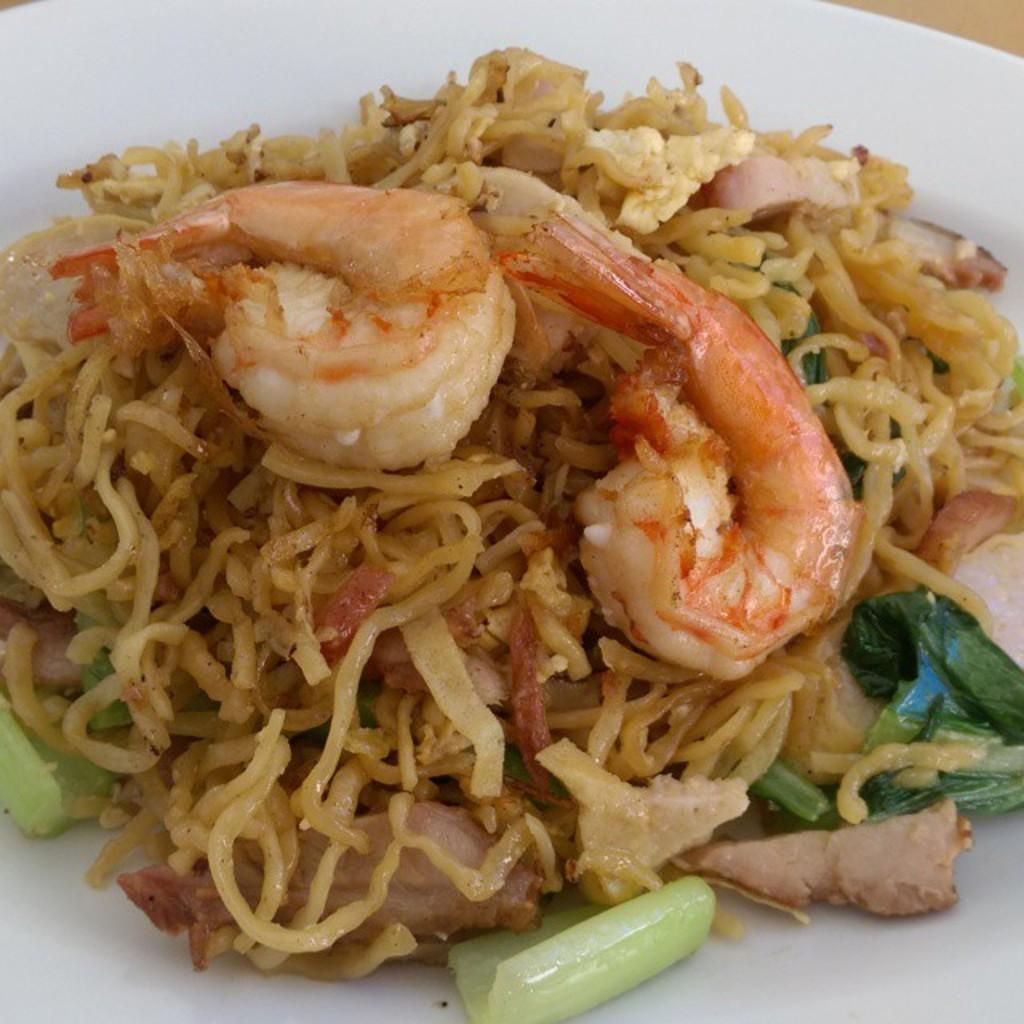What is the main subject of the image? There is a food item on a plate in the image. What time of day is the alarm set for in the image? There is no alarm present in the image. How many people are using the lift in the image? There is no lift present in the image. 